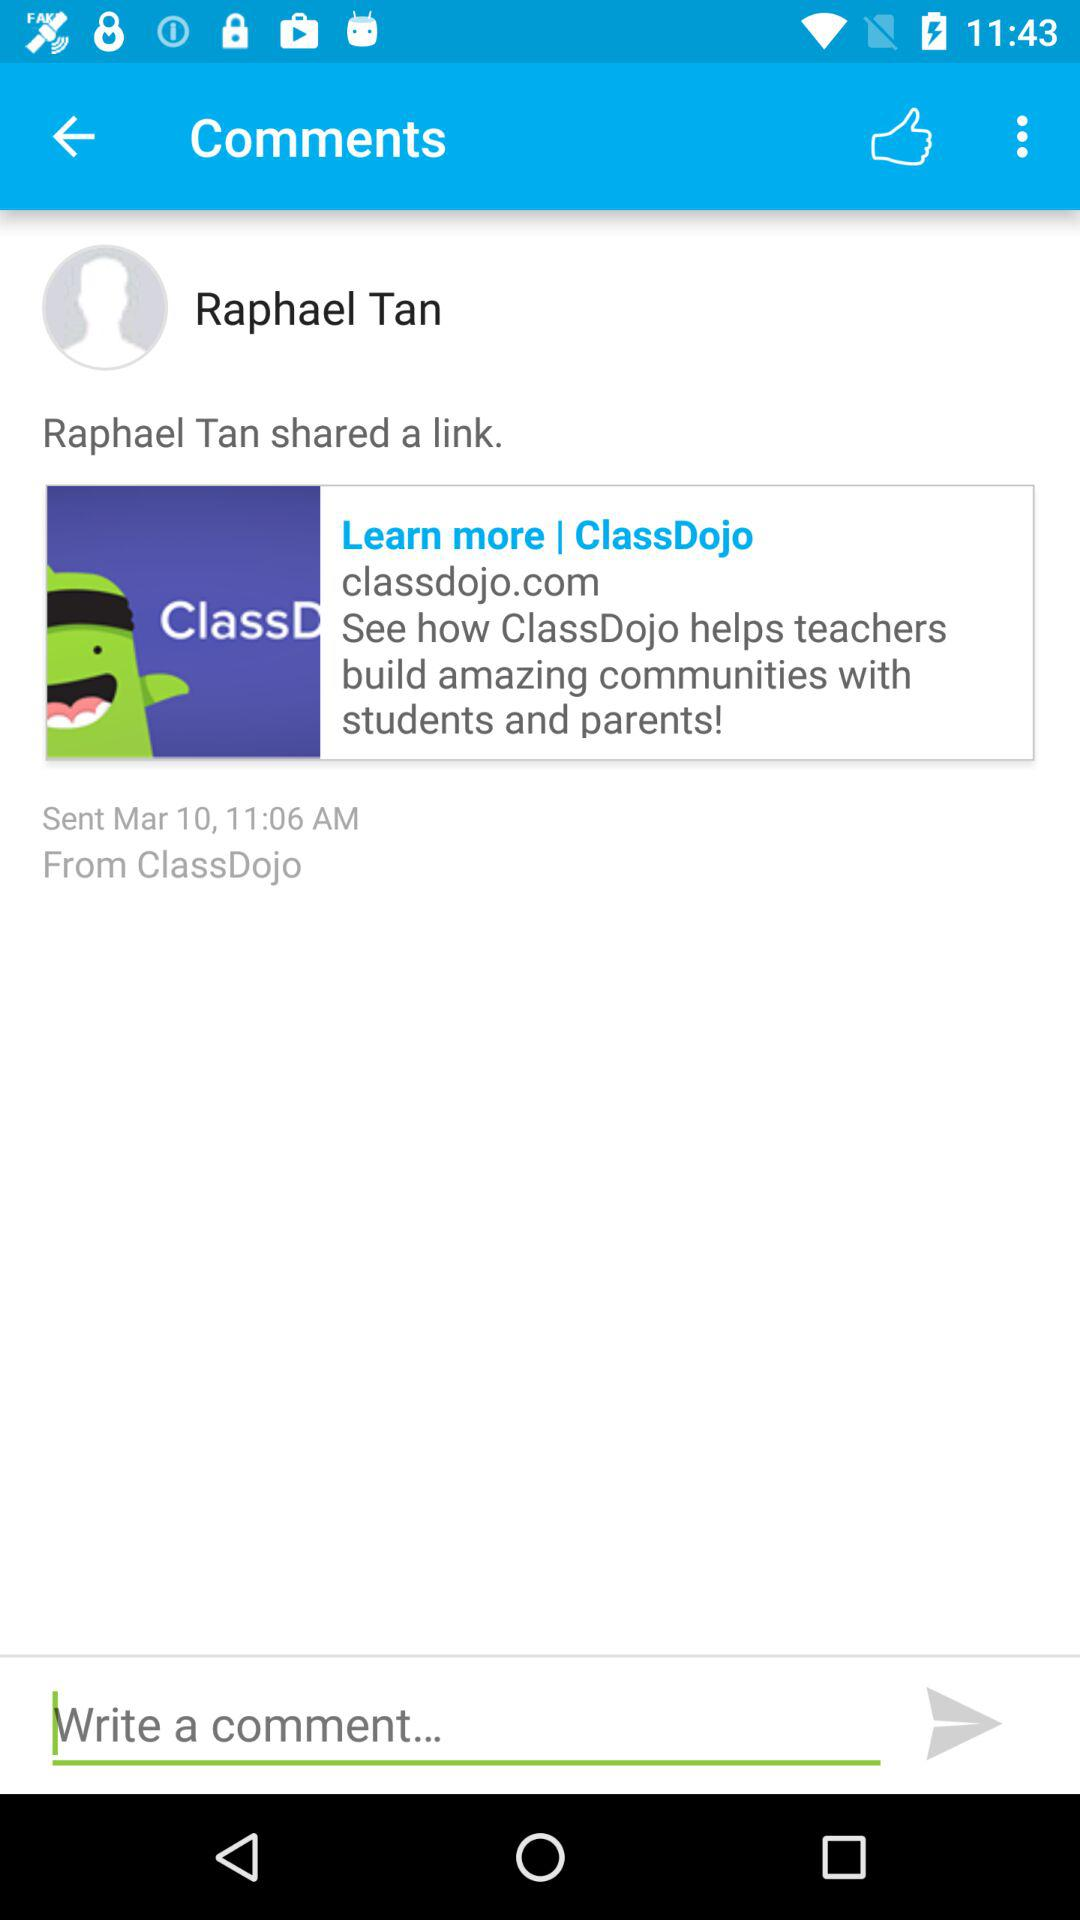At what time was the link shared? The link was shared at 11:06 a.m. 